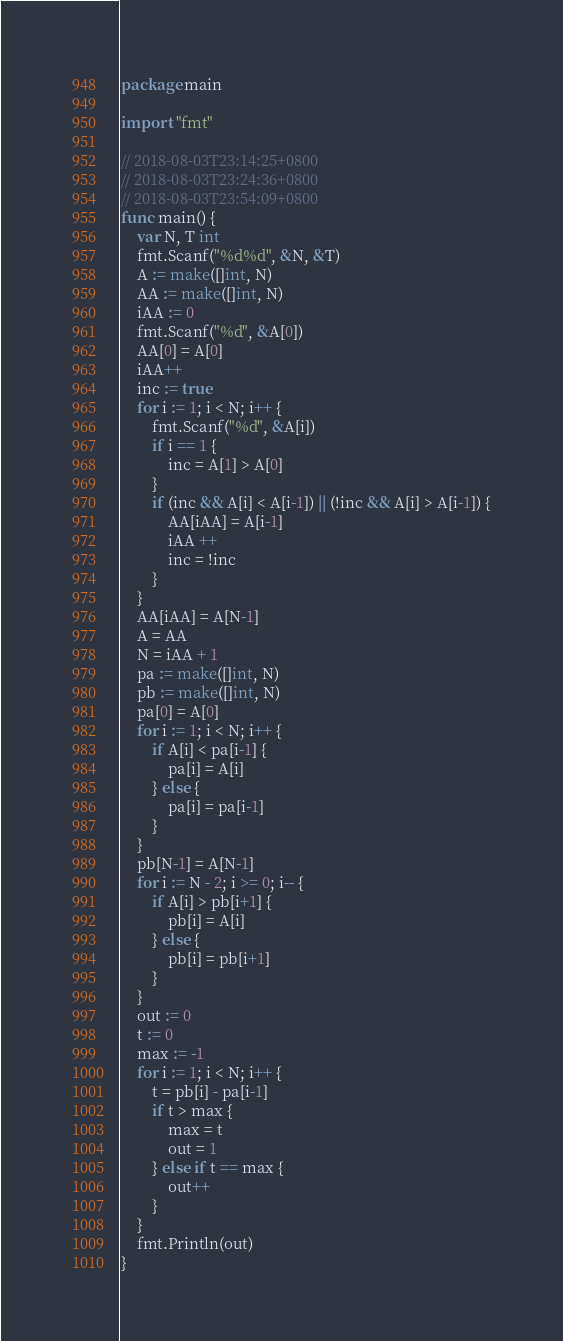<code> <loc_0><loc_0><loc_500><loc_500><_Go_>package main

import "fmt"

// 2018-08-03T23:14:25+0800
// 2018-08-03T23:24:36+0800
// 2018-08-03T23:54:09+0800
func main() {
	var N, T int
	fmt.Scanf("%d%d", &N, &T)
	A := make([]int, N)
	AA := make([]int, N)
	iAA := 0
	fmt.Scanf("%d", &A[0])
	AA[0] = A[0]
	iAA++
	inc := true
	for i := 1; i < N; i++ {
		fmt.Scanf("%d", &A[i])
		if i == 1 {
			inc = A[1] > A[0]
		}
		if (inc && A[i] < A[i-1]) || (!inc && A[i] > A[i-1]) {
			AA[iAA] = A[i-1]
			iAA ++
			inc = !inc
		}
	}
	AA[iAA] = A[N-1]
	A = AA
	N = iAA + 1
	pa := make([]int, N)
	pb := make([]int, N)
	pa[0] = A[0]
	for i := 1; i < N; i++ {
		if A[i] < pa[i-1] {
			pa[i] = A[i]
		} else {
			pa[i] = pa[i-1]
		}
	}
	pb[N-1] = A[N-1]
	for i := N - 2; i >= 0; i-- {
		if A[i] > pb[i+1] {
			pb[i] = A[i]
		} else {
			pb[i] = pb[i+1]
		}
	}
	out := 0
	t := 0
	max := -1
	for i := 1; i < N; i++ {
		t = pb[i] - pa[i-1]
		if t > max {
			max = t
			out = 1
		} else if t == max {
			out++
		}
	}
	fmt.Println(out)
}</code> 